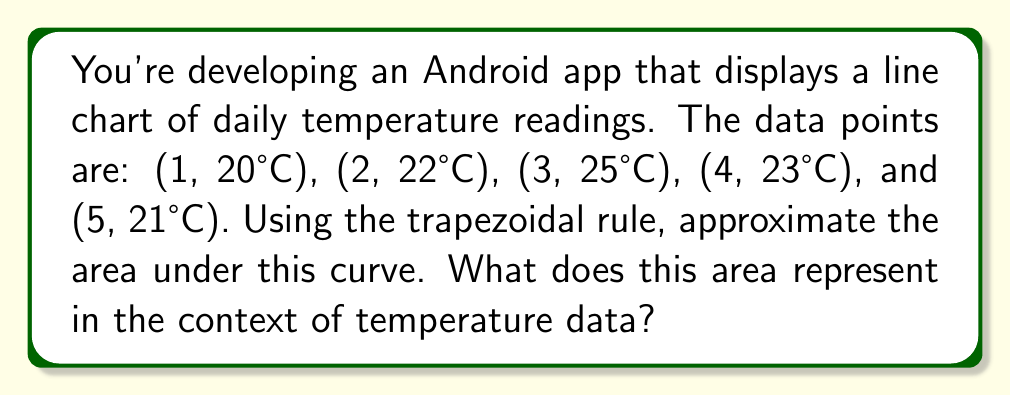Can you answer this question? Let's approach this step-by-step:

1) The trapezoidal rule approximates the area under a curve by dividing it into trapezoids. The formula is:

   $$A \approx \frac{h}{2}[f(x_0) + 2f(x_1) + 2f(x_2) + ... + 2f(x_{n-1}) + f(x_n)]$$

   where $h$ is the width of each trapezoid, and $f(x_i)$ are the y-values.

2) In our case:
   $h = 1$ (the x-values are 1 unit apart)
   $n = 4$ (we have 5 points, so 4 intervals)
   $f(x_0) = 20, f(x_1) = 22, f(x_2) = 25, f(x_3) = 23, f(x_4) = 21$

3) Plugging into the formula:

   $$A \approx \frac{1}{2}[20 + 2(22) + 2(25) + 2(23) + 21]$$

4) Simplifying:

   $$A \approx \frac{1}{2}[20 + 44 + 50 + 46 + 21] = \frac{1}{2}[181] = 90.5$$

5) The units are °C⋅days, as we're multiplying temperature (°C) by time (days).

6) In the context of temperature data, this area represents the cumulative temperature over the 5-day period. It's a measure of the total heat experienced, which could be useful for various applications like energy consumption estimation or agricultural planning.
Answer: 90.5 °C⋅days 